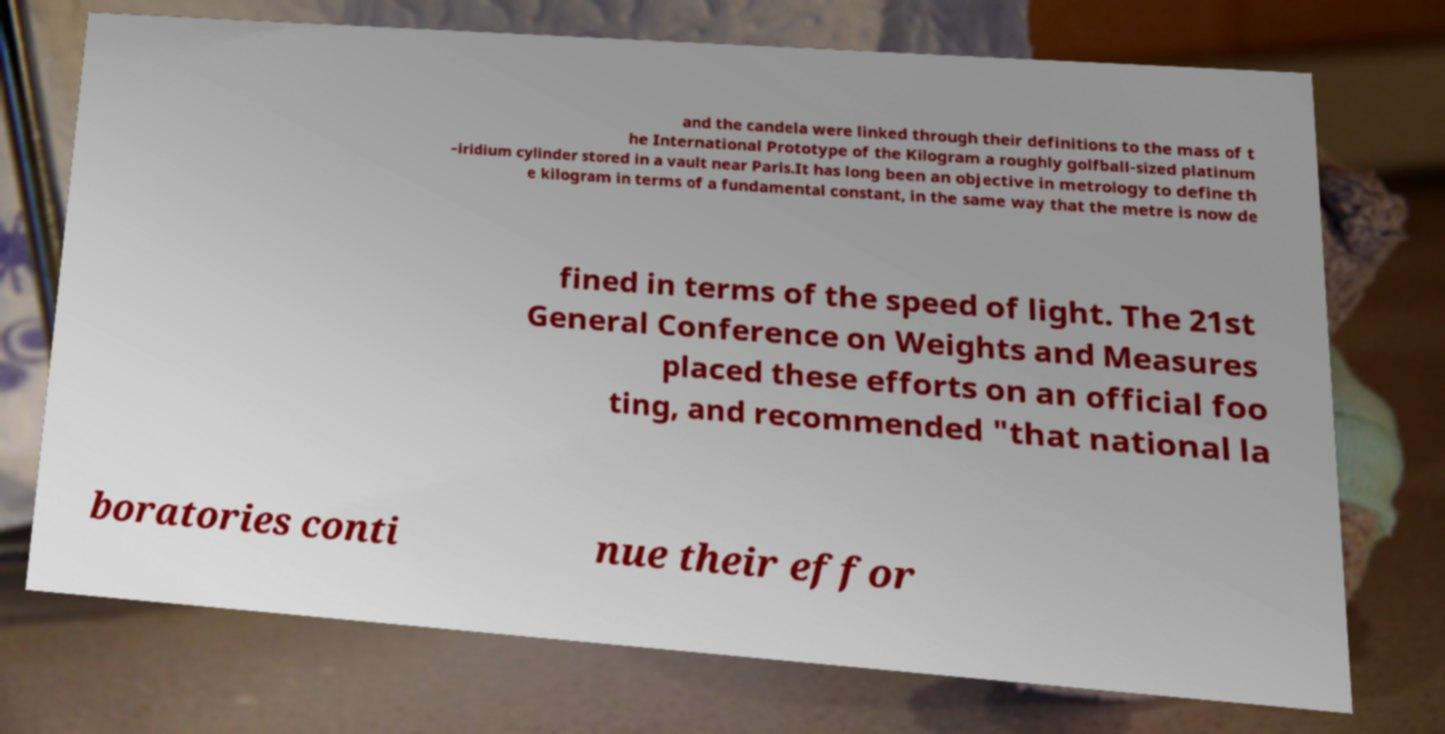Could you extract and type out the text from this image? and the candela were linked through their definitions to the mass of t he International Prototype of the Kilogram a roughly golfball-sized platinum –iridium cylinder stored in a vault near Paris.It has long been an objective in metrology to define th e kilogram in terms of a fundamental constant, in the same way that the metre is now de fined in terms of the speed of light. The 21st General Conference on Weights and Measures placed these efforts on an official foo ting, and recommended "that national la boratories conti nue their effor 